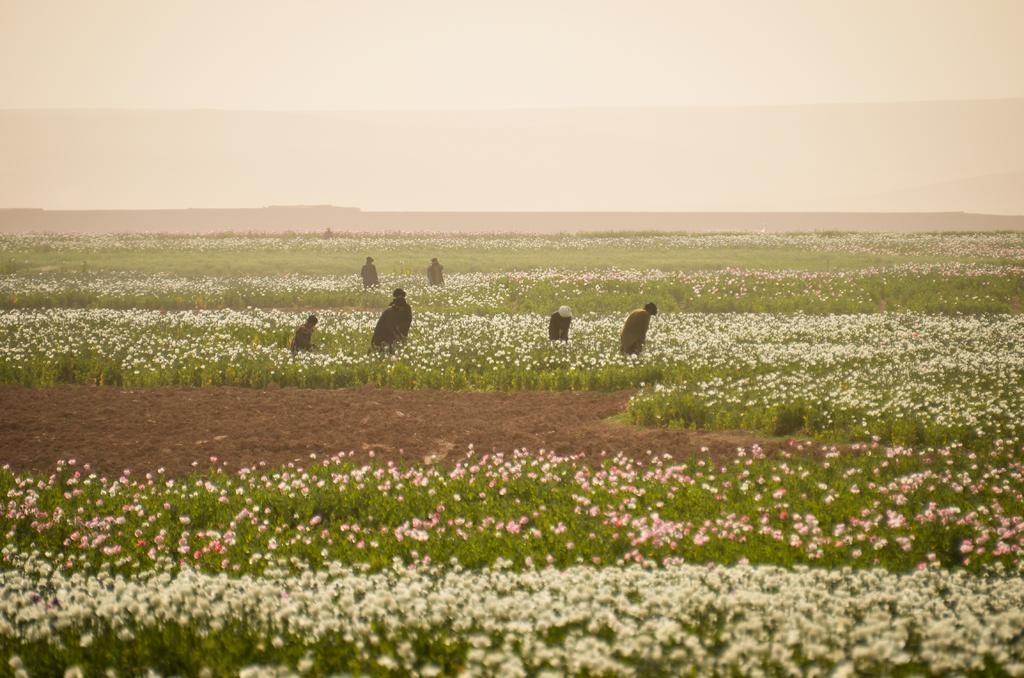What type of plants are visible in the image? There are plants with flowers in the image. Can you describe the people in the image? There are people standing in the image. What is the condition of the sky in the image? The sky is cloudy in the image. How many crackers are being held by the people in the image? There is no mention of crackers in the image, so it cannot be determined if any are being held. 